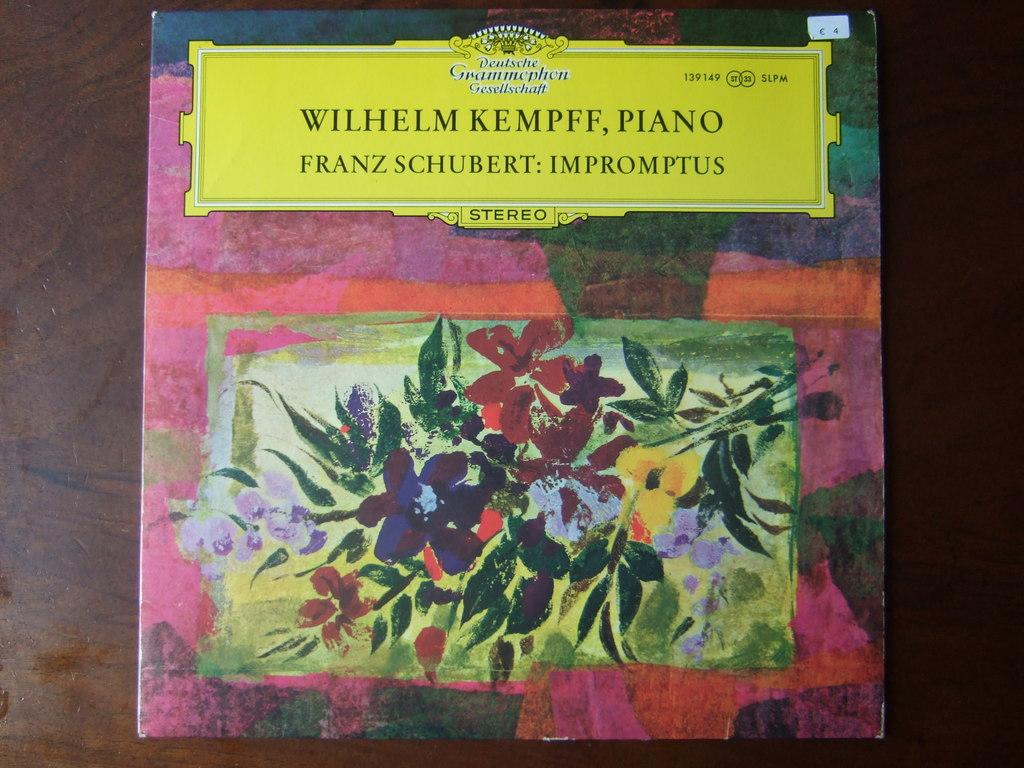<image>
Render a clear and concise summary of the photo. Wilhelm Kempff Piano Franz Schubert: Impromptus Stereo cover with flowers. 